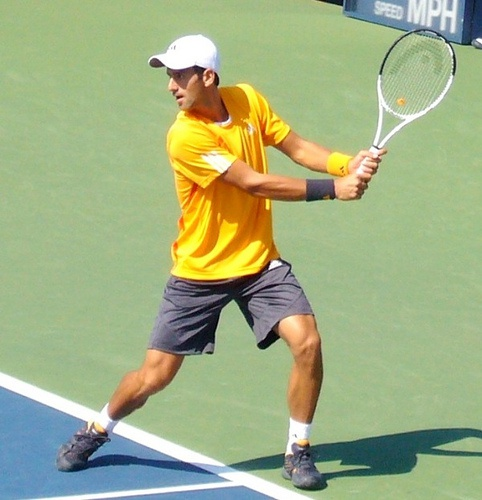Describe the objects in this image and their specific colors. I can see people in lightgreen, gold, red, tan, and darkgray tones and tennis racket in lightgreen, darkgray, beige, and ivory tones in this image. 